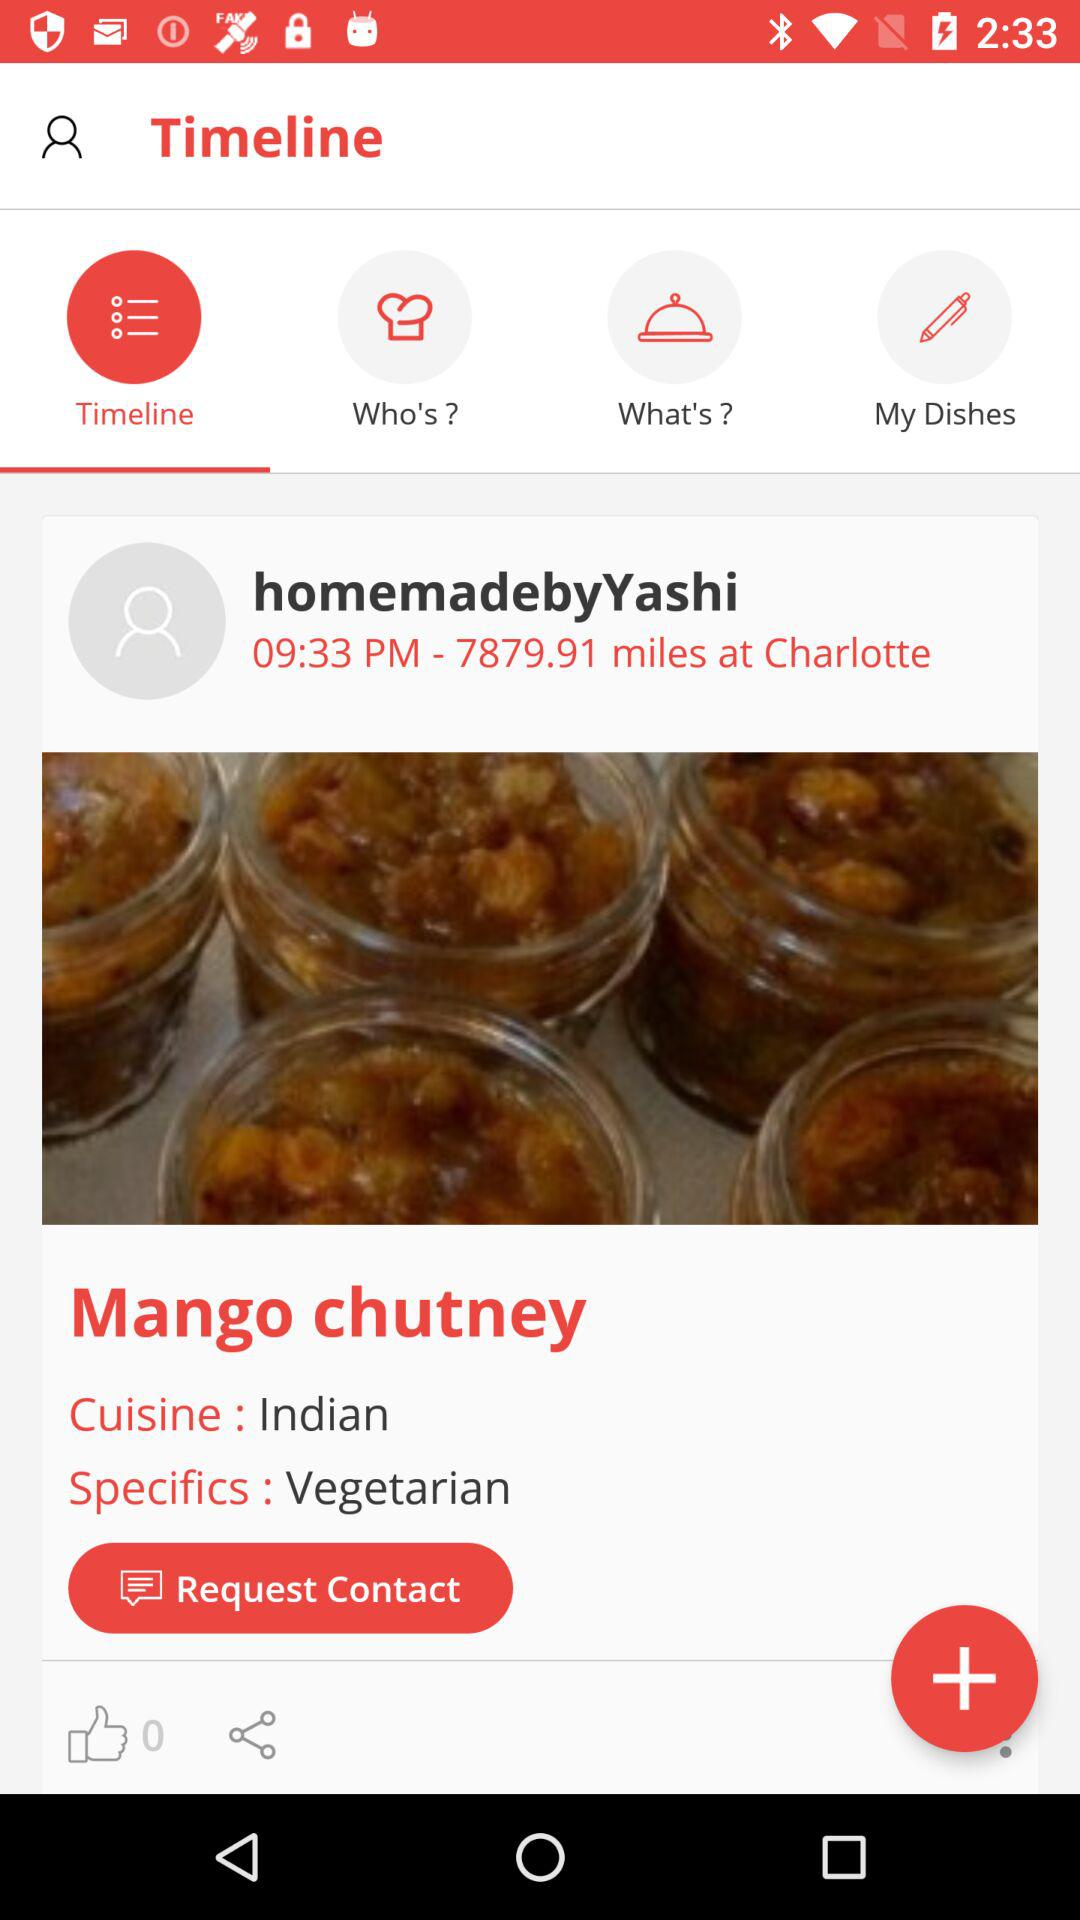How many people liked the post? The number of people who liked the post is 0. 